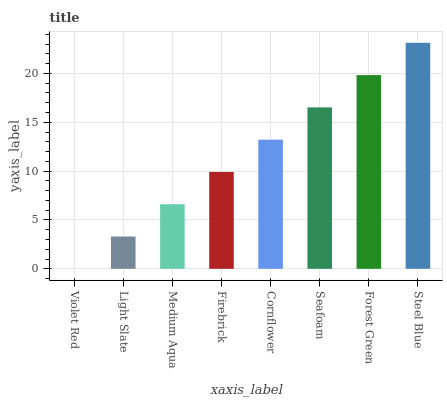Is Violet Red the minimum?
Answer yes or no. Yes. Is Steel Blue the maximum?
Answer yes or no. Yes. Is Light Slate the minimum?
Answer yes or no. No. Is Light Slate the maximum?
Answer yes or no. No. Is Light Slate greater than Violet Red?
Answer yes or no. Yes. Is Violet Red less than Light Slate?
Answer yes or no. Yes. Is Violet Red greater than Light Slate?
Answer yes or no. No. Is Light Slate less than Violet Red?
Answer yes or no. No. Is Cornflower the high median?
Answer yes or no. Yes. Is Firebrick the low median?
Answer yes or no. Yes. Is Medium Aqua the high median?
Answer yes or no. No. Is Seafoam the low median?
Answer yes or no. No. 